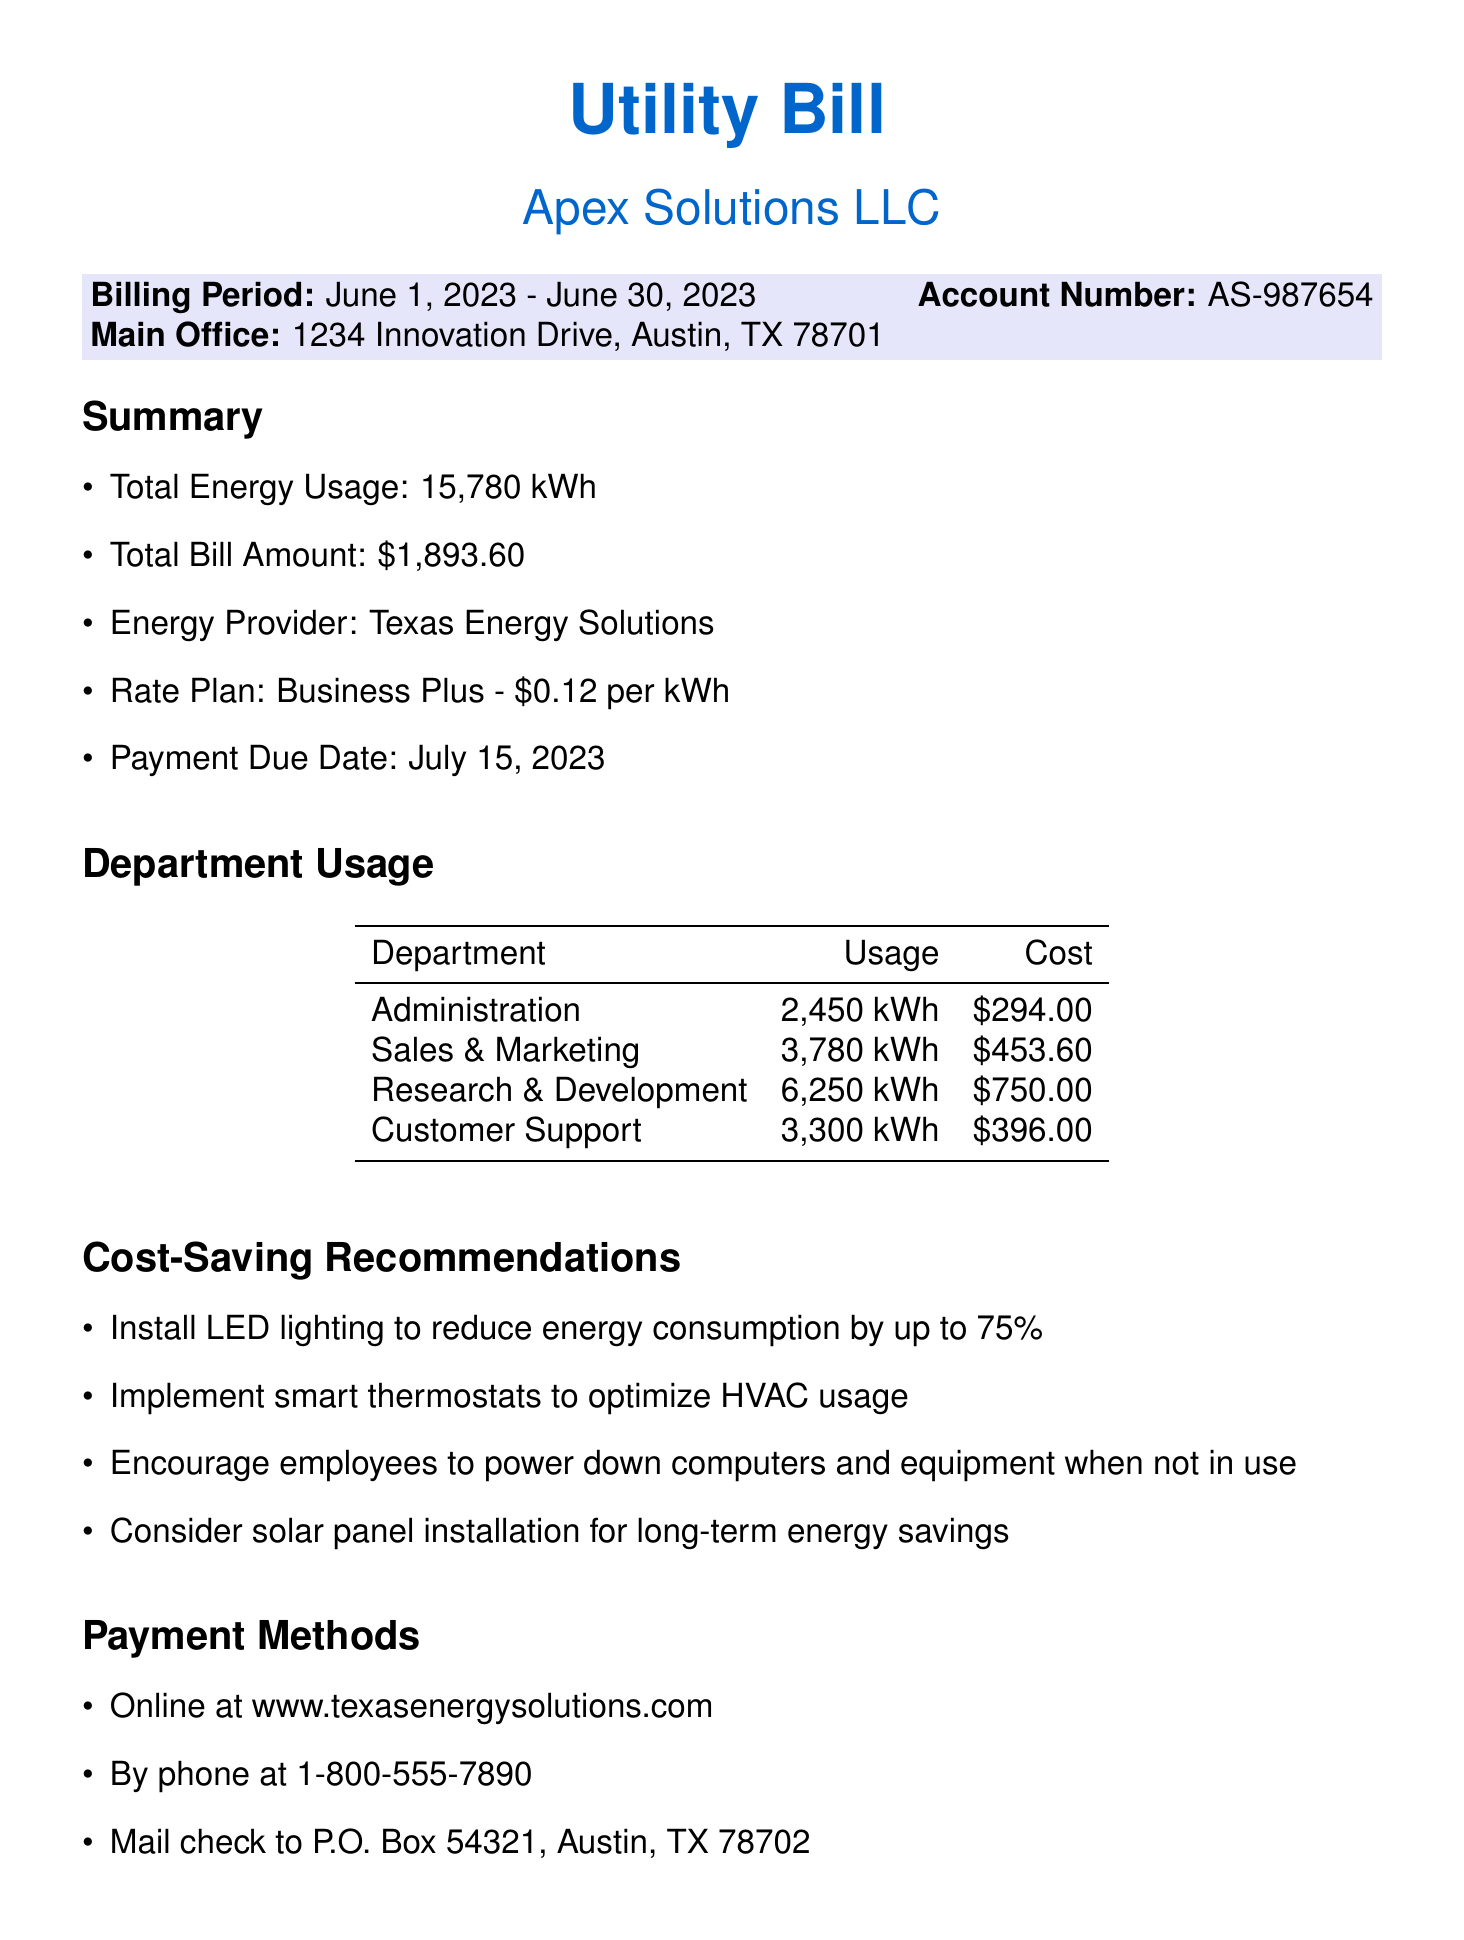What is the total energy usage? The total energy usage is listed under the summary section, which states 15,780 kWh.
Answer: 15,780 kWh What is the total bill amount? The total bill amount is provided in the summary section as $1,893.60.
Answer: $1,893.60 What is the payment due date? The payment due date is mentioned in the summary section as July 15, 2023.
Answer: July 15, 2023 Which department used the most energy? By comparing the energy usage of each department, Research & Development used the most with 6,250 kWh.
Answer: Research & Development What is the cost for the Sales & Marketing department? The cost associated with the Sales & Marketing department is provided in the table as $453.60.
Answer: $453.60 How much energy did the Customer Support department use? The document specifies that Customer Support used 3,300 kWh, found in the department usage table.
Answer: 3,300 kWh What is one cost-saving recommendation mentioned? The document lists several recommendations; one of them is to install LED lighting to reduce energy consumption.
Answer: Install LED lighting What is the energy provider's name? The energy provider is specified in the summary section as Texas Energy Solutions.
Answer: Texas Energy Solutions What is the rate per kWh in the rate plan? The rate plan indicates the cost is $0.12 per kWh as stated in the summary.
Answer: $0.12 per kWh 